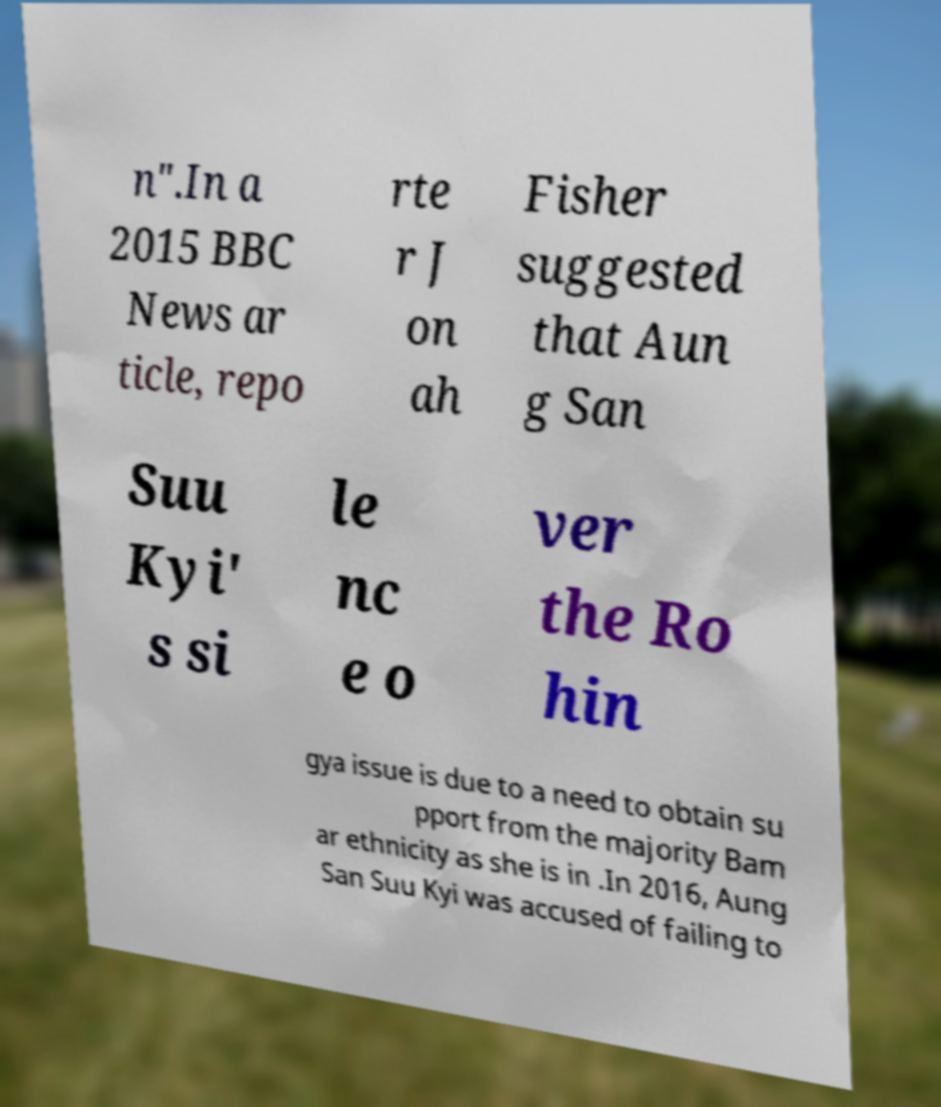Please read and relay the text visible in this image. What does it say? n".In a 2015 BBC News ar ticle, repo rte r J on ah Fisher suggested that Aun g San Suu Kyi' s si le nc e o ver the Ro hin gya issue is due to a need to obtain su pport from the majority Bam ar ethnicity as she is in .In 2016, Aung San Suu Kyi was accused of failing to 